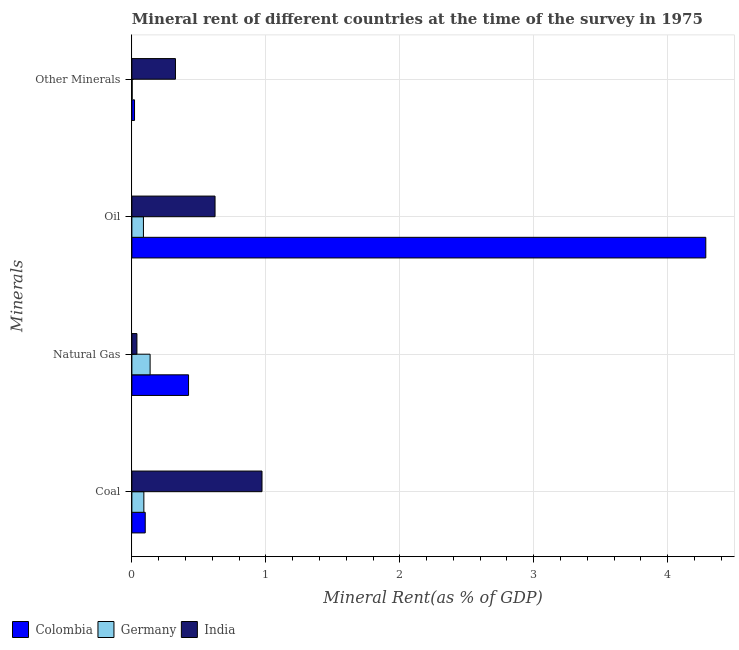Are the number of bars per tick equal to the number of legend labels?
Keep it short and to the point. Yes. Are the number of bars on each tick of the Y-axis equal?
Provide a short and direct response. Yes. How many bars are there on the 4th tick from the top?
Ensure brevity in your answer.  3. How many bars are there on the 3rd tick from the bottom?
Offer a very short reply. 3. What is the label of the 1st group of bars from the top?
Provide a short and direct response. Other Minerals. What is the natural gas rent in India?
Your answer should be very brief. 0.04. Across all countries, what is the maximum natural gas rent?
Provide a succinct answer. 0.42. Across all countries, what is the minimum  rent of other minerals?
Make the answer very short. 0. What is the total oil rent in the graph?
Your response must be concise. 4.99. What is the difference between the coal rent in India and that in Germany?
Offer a terse response. 0.88. What is the difference between the natural gas rent in India and the coal rent in Germany?
Your response must be concise. -0.05. What is the average  rent of other minerals per country?
Your answer should be compact. 0.12. What is the difference between the oil rent and  rent of other minerals in Germany?
Your answer should be very brief. 0.08. In how many countries, is the  rent of other minerals greater than 2.2 %?
Keep it short and to the point. 0. What is the ratio of the coal rent in India to that in Germany?
Give a very brief answer. 10.86. Is the natural gas rent in India less than that in Germany?
Offer a very short reply. Yes. Is the difference between the natural gas rent in Germany and Colombia greater than the difference between the oil rent in Germany and Colombia?
Your answer should be very brief. Yes. What is the difference between the highest and the second highest coal rent?
Provide a succinct answer. 0.87. What is the difference between the highest and the lowest natural gas rent?
Keep it short and to the point. 0.39. In how many countries, is the coal rent greater than the average coal rent taken over all countries?
Make the answer very short. 1. Is the sum of the  rent of other minerals in Colombia and India greater than the maximum coal rent across all countries?
Your answer should be compact. No. What does the 1st bar from the top in Natural Gas represents?
Ensure brevity in your answer.  India. What does the 2nd bar from the bottom in Other Minerals represents?
Keep it short and to the point. Germany. How many bars are there?
Your answer should be very brief. 12. Are all the bars in the graph horizontal?
Offer a terse response. Yes. How many countries are there in the graph?
Give a very brief answer. 3. Are the values on the major ticks of X-axis written in scientific E-notation?
Keep it short and to the point. No. Does the graph contain grids?
Provide a succinct answer. Yes. Where does the legend appear in the graph?
Ensure brevity in your answer.  Bottom left. What is the title of the graph?
Offer a terse response. Mineral rent of different countries at the time of the survey in 1975. Does "China" appear as one of the legend labels in the graph?
Ensure brevity in your answer.  No. What is the label or title of the X-axis?
Your answer should be compact. Mineral Rent(as % of GDP). What is the label or title of the Y-axis?
Provide a succinct answer. Minerals. What is the Mineral Rent(as % of GDP) of Colombia in Coal?
Make the answer very short. 0.1. What is the Mineral Rent(as % of GDP) in Germany in Coal?
Provide a short and direct response. 0.09. What is the Mineral Rent(as % of GDP) in India in Coal?
Your response must be concise. 0.97. What is the Mineral Rent(as % of GDP) in Colombia in Natural Gas?
Offer a very short reply. 0.42. What is the Mineral Rent(as % of GDP) of Germany in Natural Gas?
Offer a terse response. 0.14. What is the Mineral Rent(as % of GDP) in India in Natural Gas?
Keep it short and to the point. 0.04. What is the Mineral Rent(as % of GDP) in Colombia in Oil?
Your answer should be compact. 4.28. What is the Mineral Rent(as % of GDP) of Germany in Oil?
Give a very brief answer. 0.09. What is the Mineral Rent(as % of GDP) in India in Oil?
Provide a succinct answer. 0.62. What is the Mineral Rent(as % of GDP) of Colombia in Other Minerals?
Offer a very short reply. 0.02. What is the Mineral Rent(as % of GDP) of Germany in Other Minerals?
Keep it short and to the point. 0. What is the Mineral Rent(as % of GDP) in India in Other Minerals?
Provide a short and direct response. 0.33. Across all Minerals, what is the maximum Mineral Rent(as % of GDP) of Colombia?
Provide a succinct answer. 4.28. Across all Minerals, what is the maximum Mineral Rent(as % of GDP) of Germany?
Keep it short and to the point. 0.14. Across all Minerals, what is the maximum Mineral Rent(as % of GDP) of India?
Provide a succinct answer. 0.97. Across all Minerals, what is the minimum Mineral Rent(as % of GDP) of Colombia?
Your response must be concise. 0.02. Across all Minerals, what is the minimum Mineral Rent(as % of GDP) of Germany?
Your answer should be compact. 0. Across all Minerals, what is the minimum Mineral Rent(as % of GDP) in India?
Your response must be concise. 0.04. What is the total Mineral Rent(as % of GDP) in Colombia in the graph?
Ensure brevity in your answer.  4.83. What is the total Mineral Rent(as % of GDP) of Germany in the graph?
Offer a very short reply. 0.31. What is the total Mineral Rent(as % of GDP) of India in the graph?
Offer a terse response. 1.96. What is the difference between the Mineral Rent(as % of GDP) of Colombia in Coal and that in Natural Gas?
Provide a succinct answer. -0.32. What is the difference between the Mineral Rent(as % of GDP) of Germany in Coal and that in Natural Gas?
Your answer should be very brief. -0.05. What is the difference between the Mineral Rent(as % of GDP) in India in Coal and that in Natural Gas?
Your answer should be compact. 0.93. What is the difference between the Mineral Rent(as % of GDP) in Colombia in Coal and that in Oil?
Provide a short and direct response. -4.18. What is the difference between the Mineral Rent(as % of GDP) in Germany in Coal and that in Oil?
Keep it short and to the point. 0. What is the difference between the Mineral Rent(as % of GDP) of India in Coal and that in Oil?
Offer a terse response. 0.35. What is the difference between the Mineral Rent(as % of GDP) of Colombia in Coal and that in Other Minerals?
Make the answer very short. 0.08. What is the difference between the Mineral Rent(as % of GDP) of Germany in Coal and that in Other Minerals?
Your response must be concise. 0.09. What is the difference between the Mineral Rent(as % of GDP) in India in Coal and that in Other Minerals?
Make the answer very short. 0.65. What is the difference between the Mineral Rent(as % of GDP) of Colombia in Natural Gas and that in Oil?
Keep it short and to the point. -3.86. What is the difference between the Mineral Rent(as % of GDP) in Germany in Natural Gas and that in Oil?
Provide a succinct answer. 0.05. What is the difference between the Mineral Rent(as % of GDP) in India in Natural Gas and that in Oil?
Provide a short and direct response. -0.58. What is the difference between the Mineral Rent(as % of GDP) in Colombia in Natural Gas and that in Other Minerals?
Provide a succinct answer. 0.4. What is the difference between the Mineral Rent(as % of GDP) of Germany in Natural Gas and that in Other Minerals?
Provide a short and direct response. 0.13. What is the difference between the Mineral Rent(as % of GDP) of India in Natural Gas and that in Other Minerals?
Provide a short and direct response. -0.29. What is the difference between the Mineral Rent(as % of GDP) in Colombia in Oil and that in Other Minerals?
Provide a short and direct response. 4.26. What is the difference between the Mineral Rent(as % of GDP) in Germany in Oil and that in Other Minerals?
Your answer should be compact. 0.08. What is the difference between the Mineral Rent(as % of GDP) of India in Oil and that in Other Minerals?
Provide a succinct answer. 0.3. What is the difference between the Mineral Rent(as % of GDP) of Colombia in Coal and the Mineral Rent(as % of GDP) of Germany in Natural Gas?
Ensure brevity in your answer.  -0.04. What is the difference between the Mineral Rent(as % of GDP) in Colombia in Coal and the Mineral Rent(as % of GDP) in India in Natural Gas?
Give a very brief answer. 0.06. What is the difference between the Mineral Rent(as % of GDP) in Germany in Coal and the Mineral Rent(as % of GDP) in India in Natural Gas?
Give a very brief answer. 0.05. What is the difference between the Mineral Rent(as % of GDP) of Colombia in Coal and the Mineral Rent(as % of GDP) of Germany in Oil?
Give a very brief answer. 0.01. What is the difference between the Mineral Rent(as % of GDP) of Colombia in Coal and the Mineral Rent(as % of GDP) of India in Oil?
Offer a very short reply. -0.52. What is the difference between the Mineral Rent(as % of GDP) of Germany in Coal and the Mineral Rent(as % of GDP) of India in Oil?
Ensure brevity in your answer.  -0.53. What is the difference between the Mineral Rent(as % of GDP) in Colombia in Coal and the Mineral Rent(as % of GDP) in Germany in Other Minerals?
Give a very brief answer. 0.1. What is the difference between the Mineral Rent(as % of GDP) in Colombia in Coal and the Mineral Rent(as % of GDP) in India in Other Minerals?
Provide a succinct answer. -0.23. What is the difference between the Mineral Rent(as % of GDP) in Germany in Coal and the Mineral Rent(as % of GDP) in India in Other Minerals?
Offer a very short reply. -0.24. What is the difference between the Mineral Rent(as % of GDP) in Colombia in Natural Gas and the Mineral Rent(as % of GDP) in Germany in Oil?
Your answer should be compact. 0.34. What is the difference between the Mineral Rent(as % of GDP) in Colombia in Natural Gas and the Mineral Rent(as % of GDP) in India in Oil?
Give a very brief answer. -0.2. What is the difference between the Mineral Rent(as % of GDP) in Germany in Natural Gas and the Mineral Rent(as % of GDP) in India in Oil?
Your response must be concise. -0.48. What is the difference between the Mineral Rent(as % of GDP) in Colombia in Natural Gas and the Mineral Rent(as % of GDP) in Germany in Other Minerals?
Give a very brief answer. 0.42. What is the difference between the Mineral Rent(as % of GDP) in Colombia in Natural Gas and the Mineral Rent(as % of GDP) in India in Other Minerals?
Offer a very short reply. 0.1. What is the difference between the Mineral Rent(as % of GDP) in Germany in Natural Gas and the Mineral Rent(as % of GDP) in India in Other Minerals?
Your answer should be very brief. -0.19. What is the difference between the Mineral Rent(as % of GDP) of Colombia in Oil and the Mineral Rent(as % of GDP) of Germany in Other Minerals?
Ensure brevity in your answer.  4.28. What is the difference between the Mineral Rent(as % of GDP) in Colombia in Oil and the Mineral Rent(as % of GDP) in India in Other Minerals?
Provide a short and direct response. 3.96. What is the difference between the Mineral Rent(as % of GDP) in Germany in Oil and the Mineral Rent(as % of GDP) in India in Other Minerals?
Ensure brevity in your answer.  -0.24. What is the average Mineral Rent(as % of GDP) of Colombia per Minerals?
Your answer should be very brief. 1.21. What is the average Mineral Rent(as % of GDP) in Germany per Minerals?
Provide a succinct answer. 0.08. What is the average Mineral Rent(as % of GDP) of India per Minerals?
Give a very brief answer. 0.49. What is the difference between the Mineral Rent(as % of GDP) in Colombia and Mineral Rent(as % of GDP) in Germany in Coal?
Ensure brevity in your answer.  0.01. What is the difference between the Mineral Rent(as % of GDP) in Colombia and Mineral Rent(as % of GDP) in India in Coal?
Your answer should be very brief. -0.87. What is the difference between the Mineral Rent(as % of GDP) of Germany and Mineral Rent(as % of GDP) of India in Coal?
Give a very brief answer. -0.88. What is the difference between the Mineral Rent(as % of GDP) in Colombia and Mineral Rent(as % of GDP) in Germany in Natural Gas?
Your answer should be compact. 0.29. What is the difference between the Mineral Rent(as % of GDP) of Colombia and Mineral Rent(as % of GDP) of India in Natural Gas?
Offer a terse response. 0.39. What is the difference between the Mineral Rent(as % of GDP) in Germany and Mineral Rent(as % of GDP) in India in Natural Gas?
Give a very brief answer. 0.1. What is the difference between the Mineral Rent(as % of GDP) in Colombia and Mineral Rent(as % of GDP) in Germany in Oil?
Provide a short and direct response. 4.2. What is the difference between the Mineral Rent(as % of GDP) of Colombia and Mineral Rent(as % of GDP) of India in Oil?
Give a very brief answer. 3.66. What is the difference between the Mineral Rent(as % of GDP) in Germany and Mineral Rent(as % of GDP) in India in Oil?
Provide a short and direct response. -0.53. What is the difference between the Mineral Rent(as % of GDP) of Colombia and Mineral Rent(as % of GDP) of Germany in Other Minerals?
Provide a short and direct response. 0.02. What is the difference between the Mineral Rent(as % of GDP) in Colombia and Mineral Rent(as % of GDP) in India in Other Minerals?
Give a very brief answer. -0.31. What is the difference between the Mineral Rent(as % of GDP) in Germany and Mineral Rent(as % of GDP) in India in Other Minerals?
Provide a short and direct response. -0.32. What is the ratio of the Mineral Rent(as % of GDP) in Colombia in Coal to that in Natural Gas?
Ensure brevity in your answer.  0.24. What is the ratio of the Mineral Rent(as % of GDP) of Germany in Coal to that in Natural Gas?
Offer a very short reply. 0.66. What is the ratio of the Mineral Rent(as % of GDP) of India in Coal to that in Natural Gas?
Provide a short and direct response. 25.78. What is the ratio of the Mineral Rent(as % of GDP) of Colombia in Coal to that in Oil?
Your answer should be compact. 0.02. What is the ratio of the Mineral Rent(as % of GDP) of Germany in Coal to that in Oil?
Your answer should be very brief. 1.04. What is the ratio of the Mineral Rent(as % of GDP) in India in Coal to that in Oil?
Offer a very short reply. 1.56. What is the ratio of the Mineral Rent(as % of GDP) of Colombia in Coal to that in Other Minerals?
Your answer should be very brief. 5.04. What is the ratio of the Mineral Rent(as % of GDP) of Germany in Coal to that in Other Minerals?
Keep it short and to the point. 44.57. What is the ratio of the Mineral Rent(as % of GDP) in India in Coal to that in Other Minerals?
Offer a terse response. 2.99. What is the ratio of the Mineral Rent(as % of GDP) of Colombia in Natural Gas to that in Oil?
Make the answer very short. 0.1. What is the ratio of the Mineral Rent(as % of GDP) in Germany in Natural Gas to that in Oil?
Provide a succinct answer. 1.58. What is the ratio of the Mineral Rent(as % of GDP) in India in Natural Gas to that in Oil?
Provide a succinct answer. 0.06. What is the ratio of the Mineral Rent(as % of GDP) of Colombia in Natural Gas to that in Other Minerals?
Provide a short and direct response. 21.37. What is the ratio of the Mineral Rent(as % of GDP) of Germany in Natural Gas to that in Other Minerals?
Offer a terse response. 67.84. What is the ratio of the Mineral Rent(as % of GDP) of India in Natural Gas to that in Other Minerals?
Give a very brief answer. 0.12. What is the ratio of the Mineral Rent(as % of GDP) in Colombia in Oil to that in Other Minerals?
Give a very brief answer. 216.47. What is the ratio of the Mineral Rent(as % of GDP) of Germany in Oil to that in Other Minerals?
Provide a succinct answer. 43. What is the ratio of the Mineral Rent(as % of GDP) in India in Oil to that in Other Minerals?
Provide a succinct answer. 1.91. What is the difference between the highest and the second highest Mineral Rent(as % of GDP) of Colombia?
Provide a succinct answer. 3.86. What is the difference between the highest and the second highest Mineral Rent(as % of GDP) of Germany?
Offer a terse response. 0.05. What is the difference between the highest and the second highest Mineral Rent(as % of GDP) in India?
Give a very brief answer. 0.35. What is the difference between the highest and the lowest Mineral Rent(as % of GDP) of Colombia?
Give a very brief answer. 4.26. What is the difference between the highest and the lowest Mineral Rent(as % of GDP) in Germany?
Your answer should be very brief. 0.13. What is the difference between the highest and the lowest Mineral Rent(as % of GDP) of India?
Give a very brief answer. 0.93. 